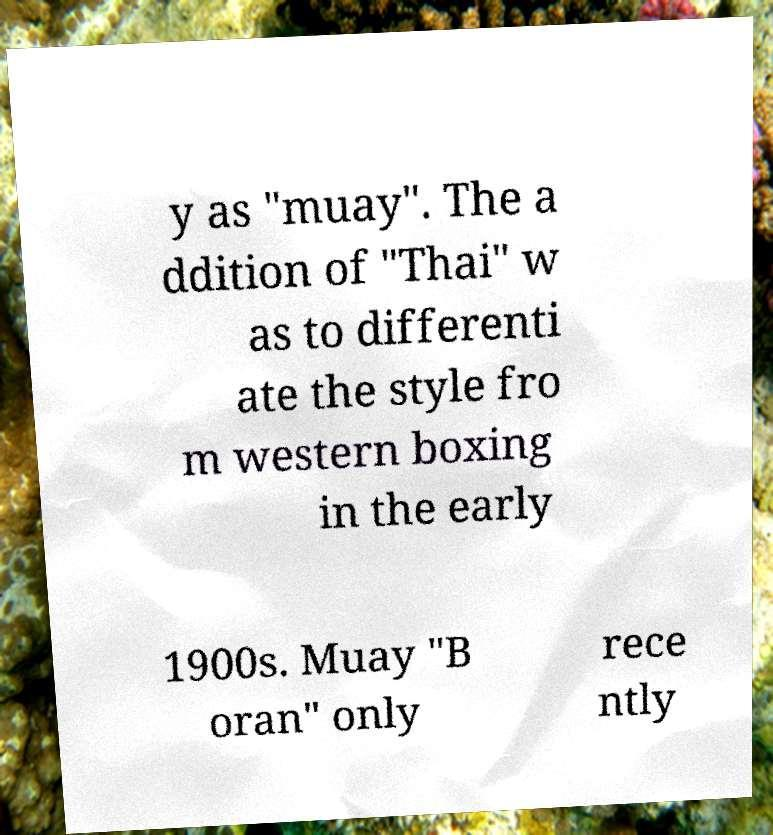Could you extract and type out the text from this image? y as "muay". The a ddition of "Thai" w as to differenti ate the style fro m western boxing in the early 1900s. Muay "B oran" only rece ntly 